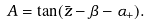<formula> <loc_0><loc_0><loc_500><loc_500>A = \tan ( \bar { z } - \beta - \alpha _ { + } ) .</formula> 